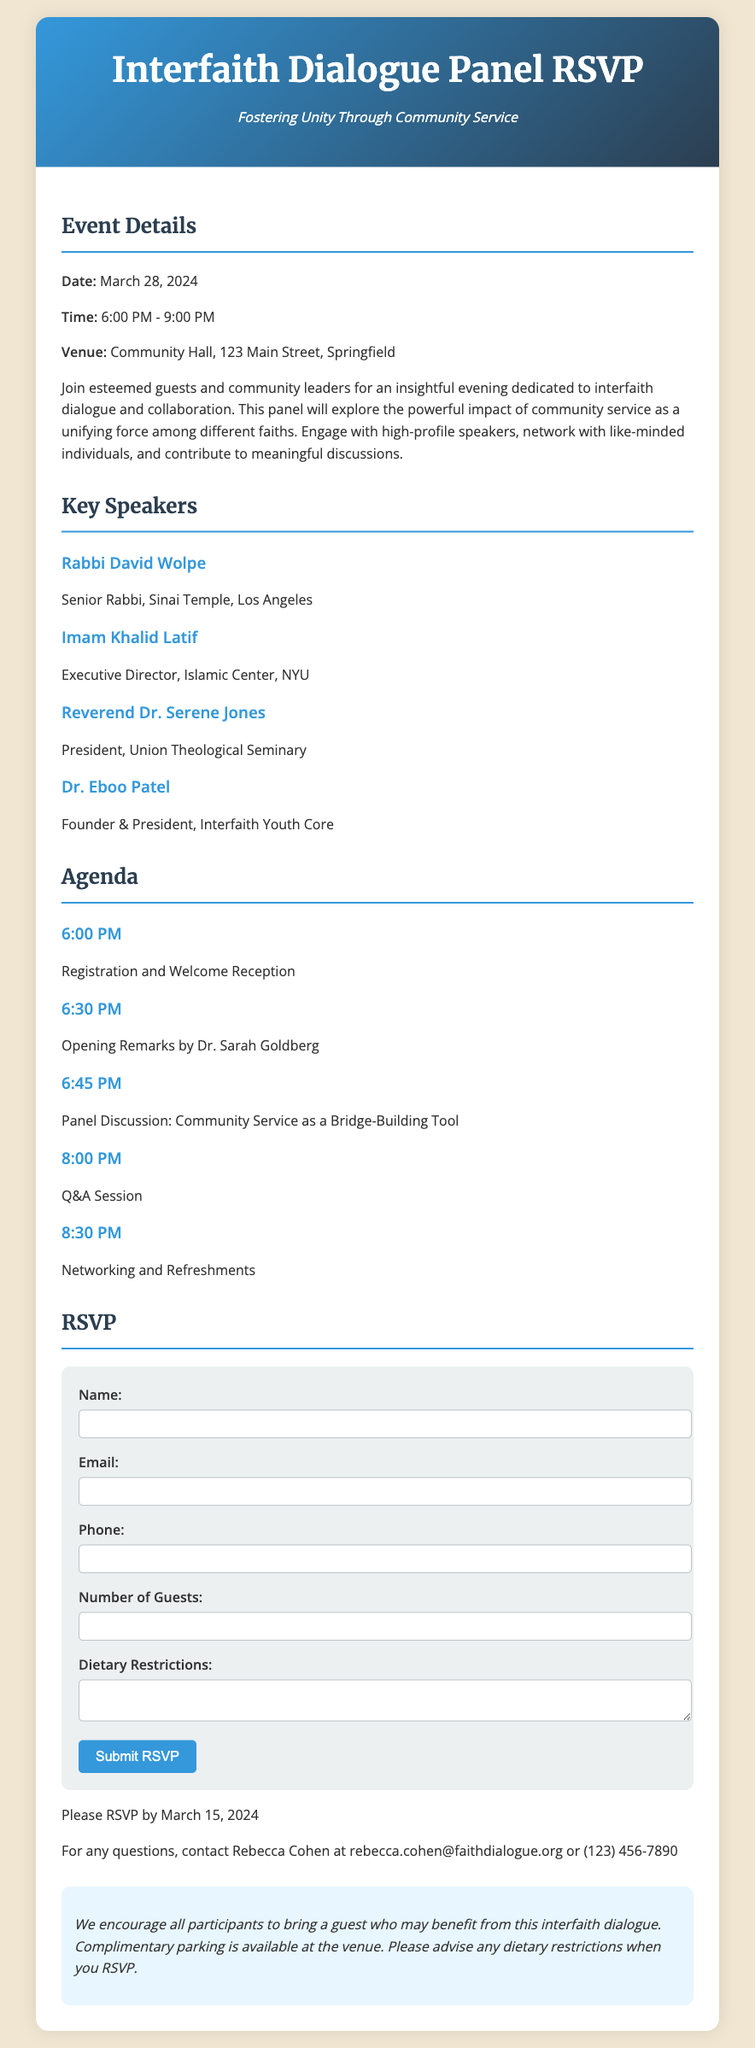what is the date of the event? The date of the event is explicitly mentioned in the event details section.
Answer: March 28, 2024 what time does the event start? The time of the event start is listed in the event details section.
Answer: 6:00 PM who is one of the key speakers? The document provides a list of key speakers, thus any name from that list serves as an answer.
Answer: Rabbi David Wolpe how many guests can I RSVP for? The RSVP section specifies the maximum number of guests allowed.
Answer: 2 what is the venue of the event? The venue is clearly stated in the event details portion of the document.
Answer: Community Hall, 123 Main Street, Springfield who is the main contact for questions? The contact information section provides the name of the person to reach out to for inquiries.
Answer: Rebecca Cohen what type of panel discussion will occur at 6:45 PM? The specific agenda item includes a description of the panel discussion for that time.
Answer: Community Service as a Bridge-Building Tool when is the RSVP deadline? The document states the last date by which participants should RSVP.
Answer: March 15, 2024 what should participants bring? The additional notes section mentions what participants are encouraged to bring.
Answer: a guest 